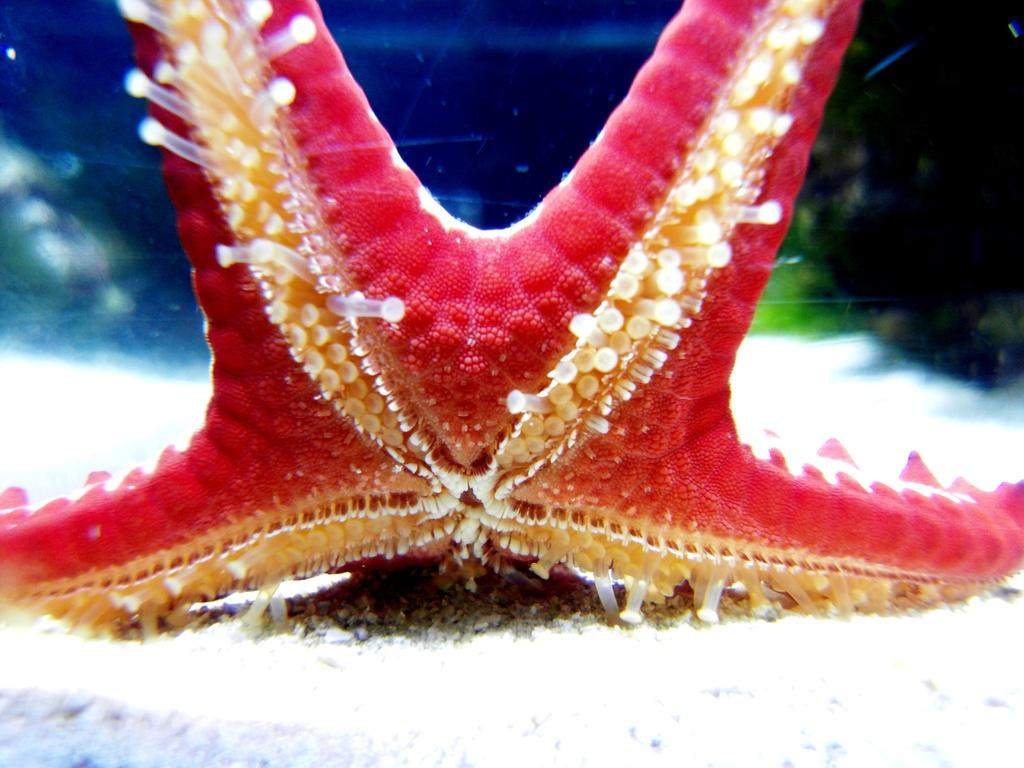Where is the image taken? The image is taken in the water. What is the main subject of the image? There is a starfish in the middle of the image. What color is the background of the image? The background of the image is blue. What color is the bottom of the image? The bottom of the image is white. How many men are visible in the image? There are no men present in the image. 